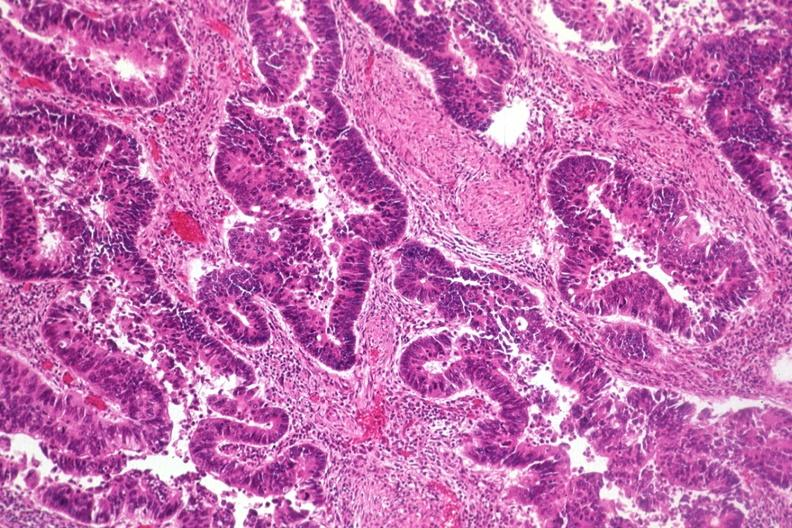s gastrointestinal present?
Answer the question using a single word or phrase. Yes 